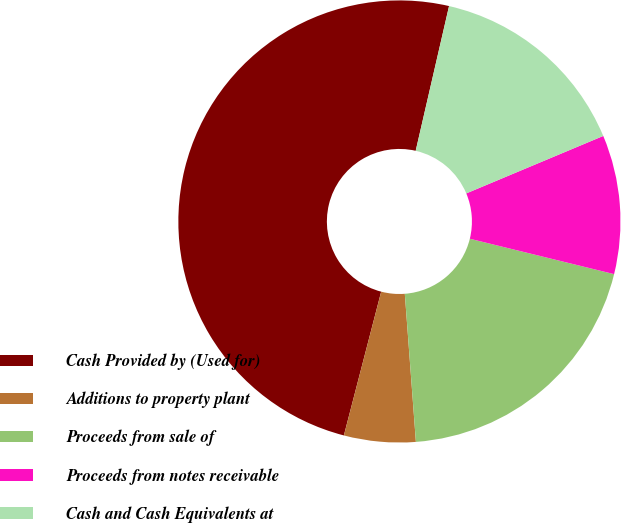<chart> <loc_0><loc_0><loc_500><loc_500><pie_chart><fcel>Cash Provided by (Used for)<fcel>Additions to property plant<fcel>Proceeds from sale of<fcel>Proceeds from notes receivable<fcel>Cash and Cash Equivalents at<nl><fcel>49.56%<fcel>5.23%<fcel>19.98%<fcel>10.15%<fcel>15.07%<nl></chart> 